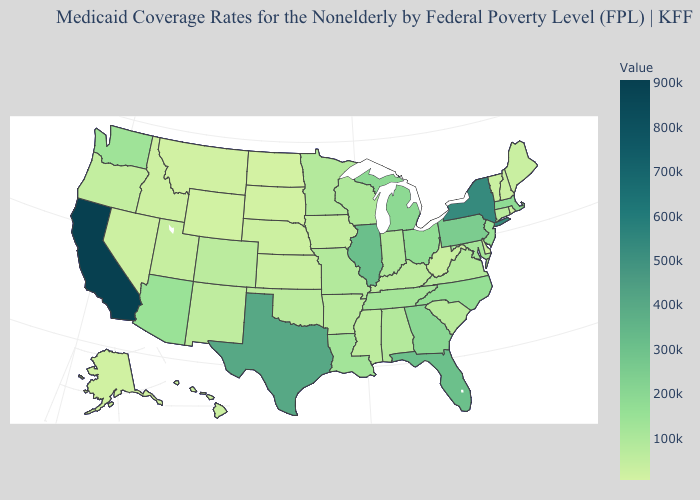Among the states that border South Dakota , which have the highest value?
Answer briefly. Minnesota. Does the map have missing data?
Quick response, please. No. Is the legend a continuous bar?
Concise answer only. Yes. Does the map have missing data?
Keep it brief. No. 